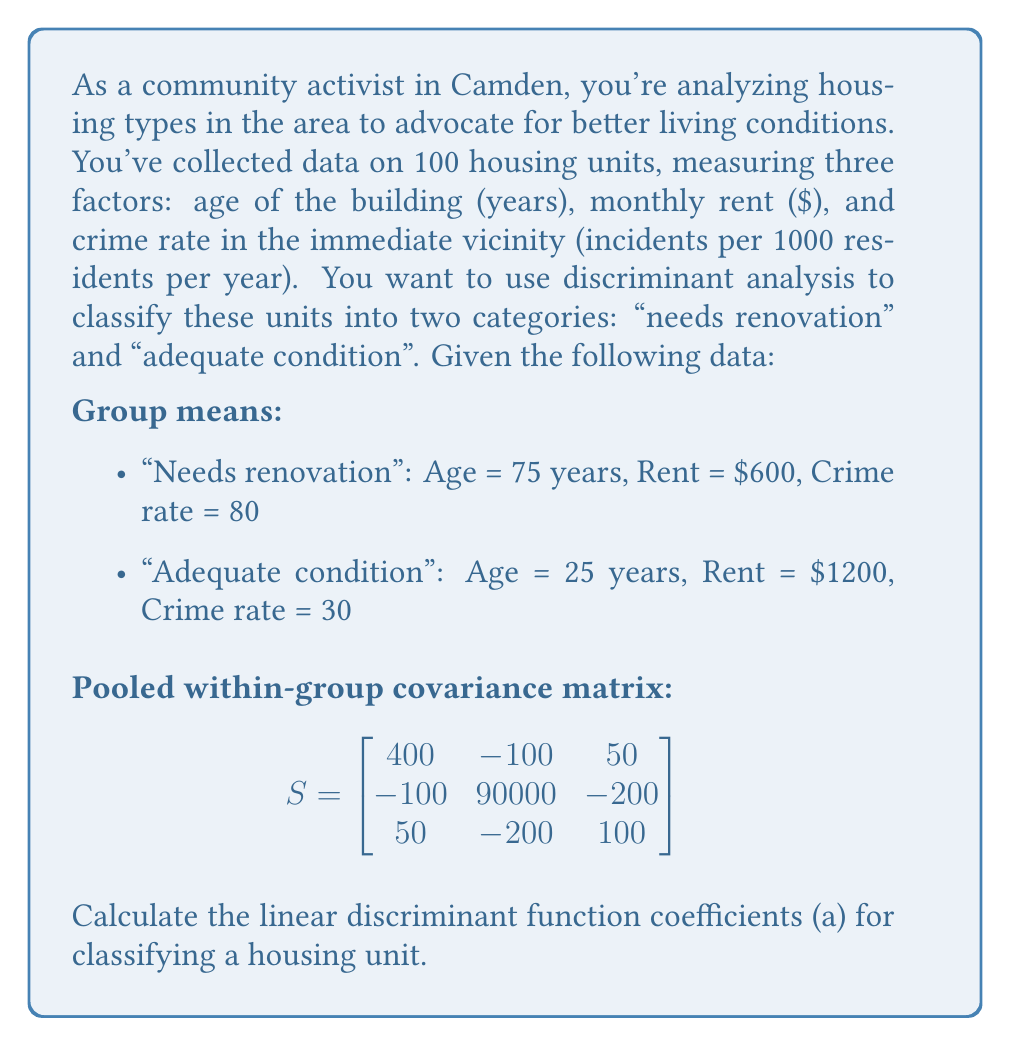Can you solve this math problem? To calculate the linear discriminant function coefficients, we'll follow these steps:

1) The linear discriminant function is of the form:
   $$a'x = a_1x_1 + a_2x_2 + a_3x_3$$
   where $x_1$, $x_2$, and $x_3$ represent age, rent, and crime rate respectively.

2) The formula for the coefficients is:
   $$a = S^{-1}(\bar{x}_1 - \bar{x}_2)$$
   where $S^{-1}$ is the inverse of the pooled within-group covariance matrix, and $\bar{x}_1$ and $\bar{x}_2$ are the mean vectors for the two groups.

3) First, let's calculate $(\bar{x}_1 - \bar{x}_2)$:
   $$\bar{x}_1 - \bar{x}_2 = \begin{bmatrix}
   75 - 25 \\
   600 - 1200 \\
   80 - 30
   \end{bmatrix} = \begin{bmatrix}
   50 \\
   -600 \\
   50
   \end{bmatrix}$$

4) Now we need to find $S^{-1}$. Using a calculator or computer, we get:
   $$S^{-1} = \begin{bmatrix}
   0.00253 & 0.00000279 & -0.00126 \\
   0.00000279 & 0.0000111 & 0.0000221 \\
   -0.00126 & 0.0000221 & 0.0102
   \end{bmatrix}$$

5) Now we multiply $S^{-1}$ by $(\bar{x}_1 - \bar{x}_2)$:
   $$a = S^{-1}(\bar{x}_1 - \bar{x}_2) = \begin{bmatrix}
   0.00253 & 0.00000279 & -0.00126 \\
   0.00000279 & 0.0000111 & 0.0000221 \\
   -0.00126 & 0.0000221 & 0.0102
   \end{bmatrix} \begin{bmatrix}
   50 \\
   -600 \\
   50
   \end{bmatrix}$$

6) Performing this matrix multiplication:
   $$a = \begin{bmatrix}
   0.1265 - 0.001674 - 0.063 \\
   0.0001395 - 0.00666 + 0.001105 \\
   -0.063 - 0.01326 + 0.51
   \end{bmatrix} = \begin{bmatrix}
   0.06183 \\
   -0.00542 \\
   0.43374
   \end{bmatrix}$$

Therefore, the linear discriminant function is:
$$0.06183x_1 - 0.00542x_2 + 0.43374x_3$$
Answer: $a = [0.06183, -0.00542, 0.43374]$ 